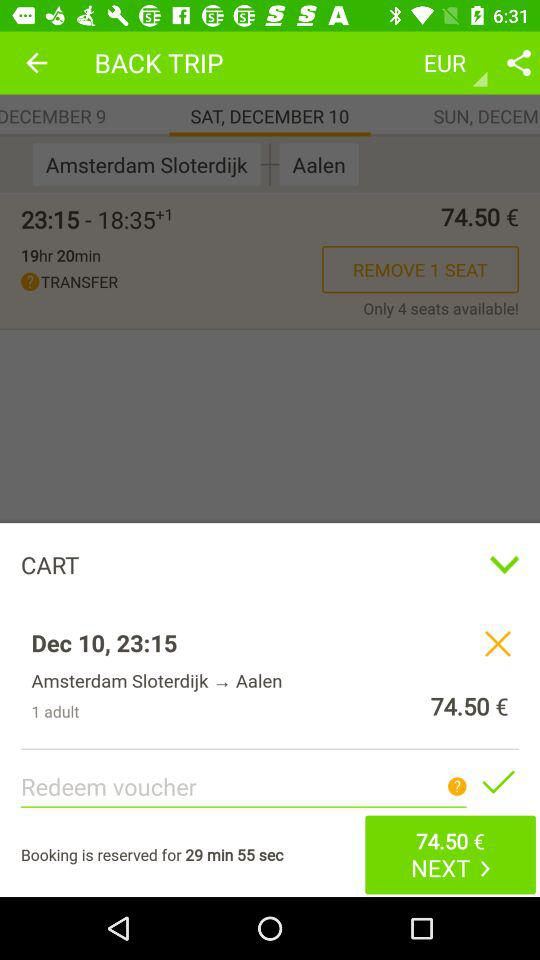How long is the booking reserved for? The booking is reserved for 29 minutes 55 seconds. 